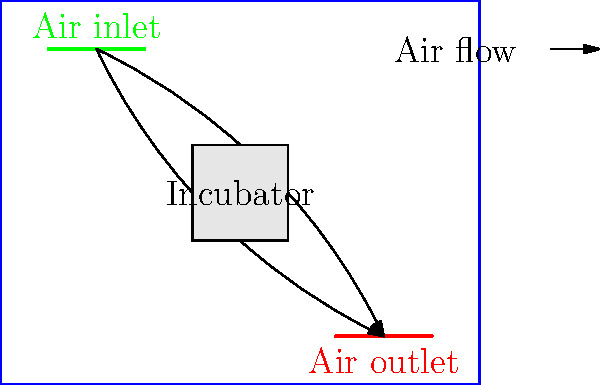In designing a sustainable HVAC system for a neonatal intensive care unit (NICU), which air flow pattern is most crucial for maintaining a sterile environment around the incubator while minimizing energy consumption? To answer this question, we need to consider several factors:

1. Sterile environment: The primary concern in a NICU is maintaining a sterile environment around the incubator to protect vulnerable newborns.

2. Energy efficiency: A sustainable HVAC system should minimize energy consumption while maintaining optimal conditions.

3. Air flow patterns: The diagram shows two main air flow patterns from the inlet to the outlet, both passing near the incubator.

4. Laminar vs. turbulent flow: Laminar flow (smooth, predictable) is generally preferred over turbulent flow in healthcare settings to reduce the spread of airborne contaminants.

5. Air distribution: The upper air flow pattern provides more even distribution of air throughout the room, while the lower pattern is more direct.

6. Temperature control: The upper air flow pattern allows for better temperature stratification, which can help maintain a consistent temperature around the incubator.

7. Energy efficiency: The upper air flow pattern requires less energy to circulate air effectively throughout the room compared to the more direct lower pattern.

Considering these factors, the upper air flow pattern (from inlet, curving above the incubator, to the outlet) is most crucial for maintaining a sterile environment while minimizing energy consumption. This pattern provides:

a) Better overall air distribution
b) Reduced risk of introducing contaminants directly to the incubator area
c) More efficient temperature control
d) Lower energy consumption due to natural air circulation patterns
Answer: Upper air flow pattern (curving above the incubator) 